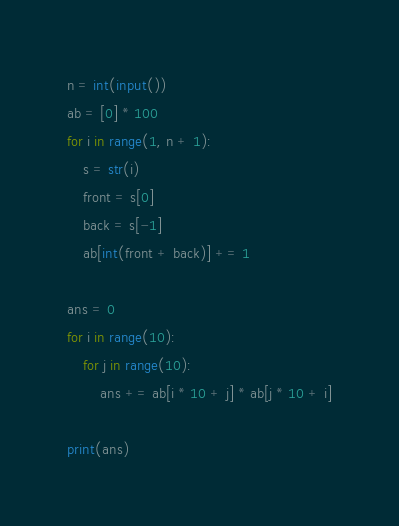Convert code to text. <code><loc_0><loc_0><loc_500><loc_500><_Python_>n = int(input())
ab = [0] * 100
for i in range(1, n + 1):
    s = str(i)
    front = s[0]
    back = s[-1]
    ab[int(front + back)] += 1

ans = 0
for i in range(10):
    for j in range(10):
        ans += ab[i * 10 + j] * ab[j * 10 + i]

print(ans)
</code> 